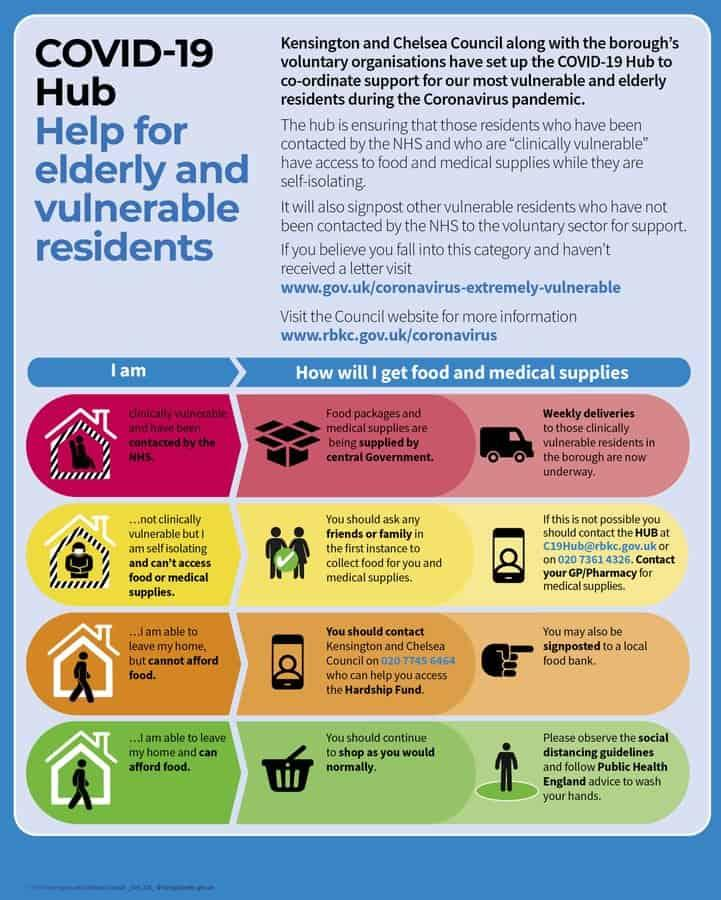Mention a couple of crucial points in this snapshot. It is possible for two individuals to leave their own homes. 